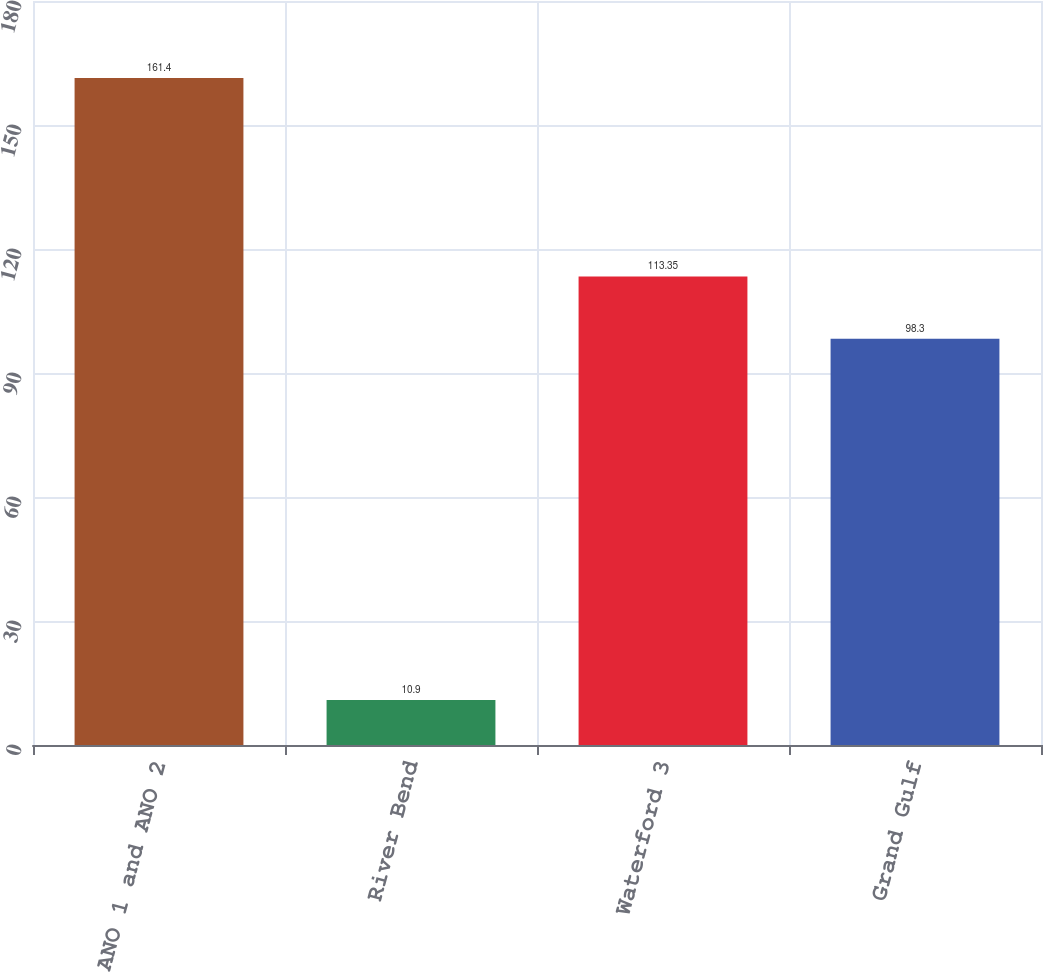Convert chart. <chart><loc_0><loc_0><loc_500><loc_500><bar_chart><fcel>ANO 1 and ANO 2<fcel>River Bend<fcel>Waterford 3<fcel>Grand Gulf<nl><fcel>161.4<fcel>10.9<fcel>113.35<fcel>98.3<nl></chart> 